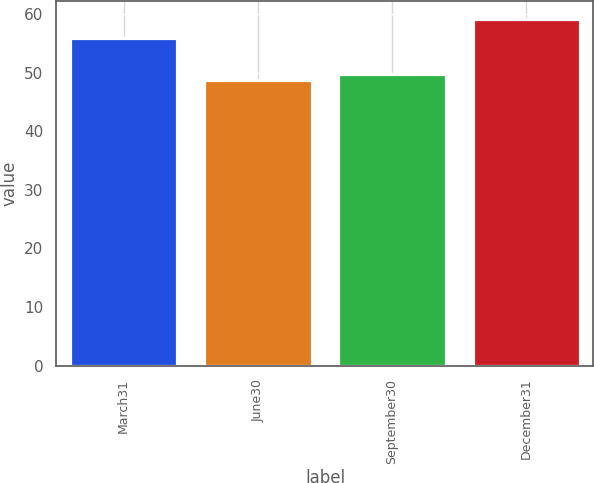Convert chart to OTSL. <chart><loc_0><loc_0><loc_500><loc_500><bar_chart><fcel>March31<fcel>June30<fcel>September30<fcel>December31<nl><fcel>55.89<fcel>48.7<fcel>49.75<fcel>59.23<nl></chart> 